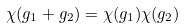<formula> <loc_0><loc_0><loc_500><loc_500>\chi ( g _ { 1 } + g _ { 2 } ) = \chi ( g _ { 1 } ) \chi ( g _ { 2 } )</formula> 